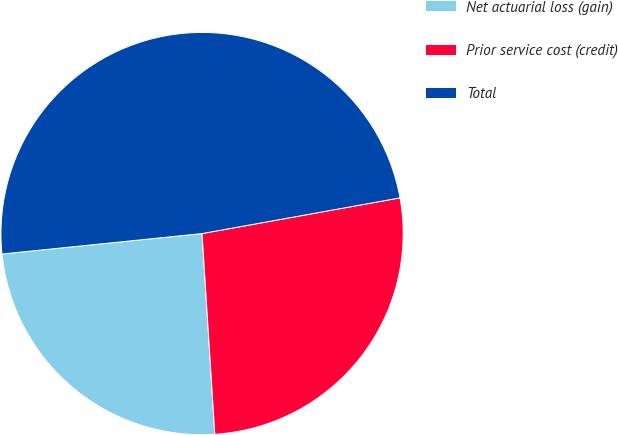<chart> <loc_0><loc_0><loc_500><loc_500><pie_chart><fcel>Net actuarial loss (gain)<fcel>Prior service cost (credit)<fcel>Total<nl><fcel>24.39%<fcel>26.83%<fcel>48.78%<nl></chart> 